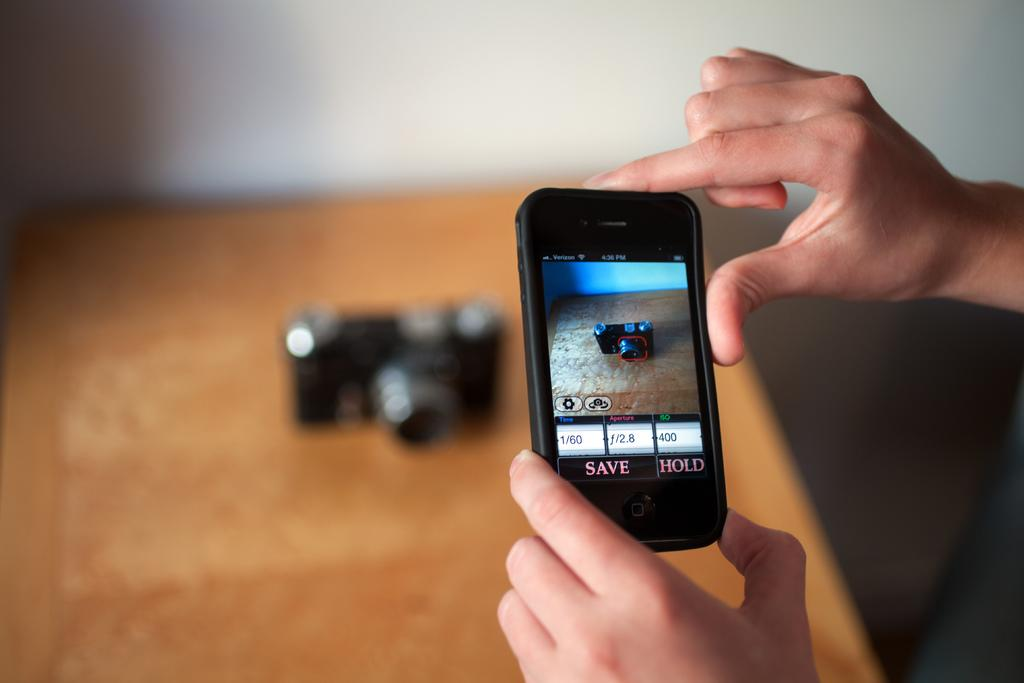<image>
Create a compact narrative representing the image presented. Hands holding a cell phone with a save and hold on it taking a picture of a camera. 